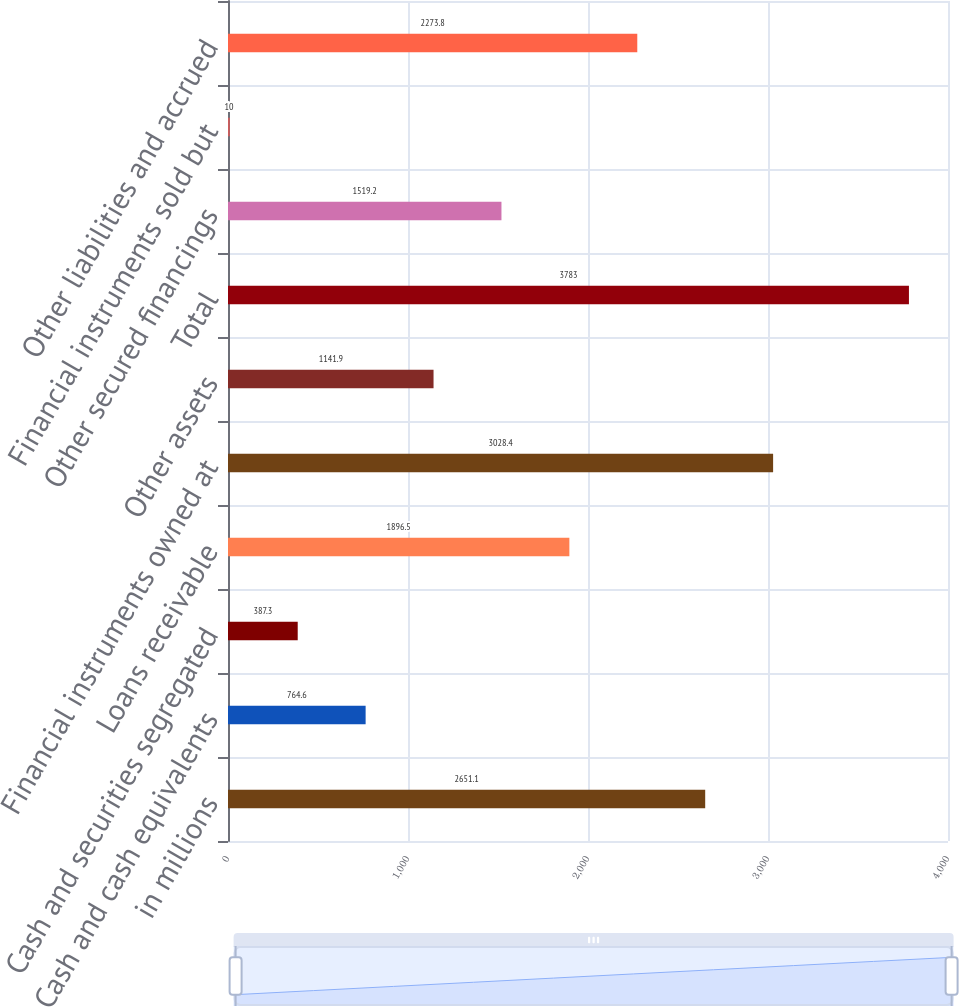Convert chart to OTSL. <chart><loc_0><loc_0><loc_500><loc_500><bar_chart><fcel>in millions<fcel>Cash and cash equivalents<fcel>Cash and securities segregated<fcel>Loans receivable<fcel>Financial instruments owned at<fcel>Other assets<fcel>Total<fcel>Other secured financings<fcel>Financial instruments sold but<fcel>Other liabilities and accrued<nl><fcel>2651.1<fcel>764.6<fcel>387.3<fcel>1896.5<fcel>3028.4<fcel>1141.9<fcel>3783<fcel>1519.2<fcel>10<fcel>2273.8<nl></chart> 